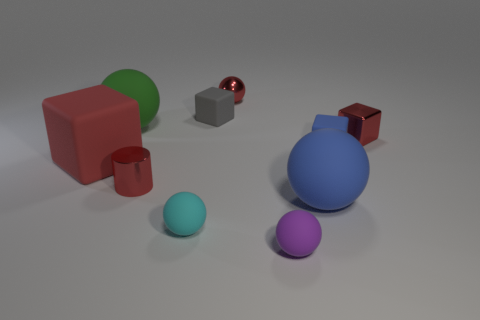How many purple spheres are the same size as the green rubber sphere? 0 